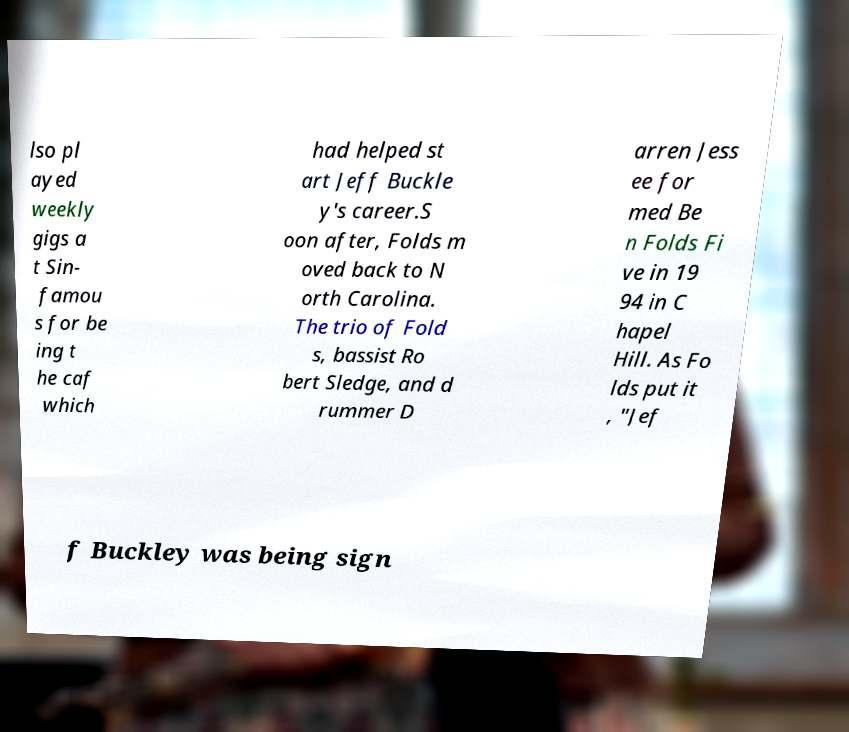For documentation purposes, I need the text within this image transcribed. Could you provide that? lso pl ayed weekly gigs a t Sin- famou s for be ing t he caf which had helped st art Jeff Buckle y's career.S oon after, Folds m oved back to N orth Carolina. The trio of Fold s, bassist Ro bert Sledge, and d rummer D arren Jess ee for med Be n Folds Fi ve in 19 94 in C hapel Hill. As Fo lds put it , "Jef f Buckley was being sign 